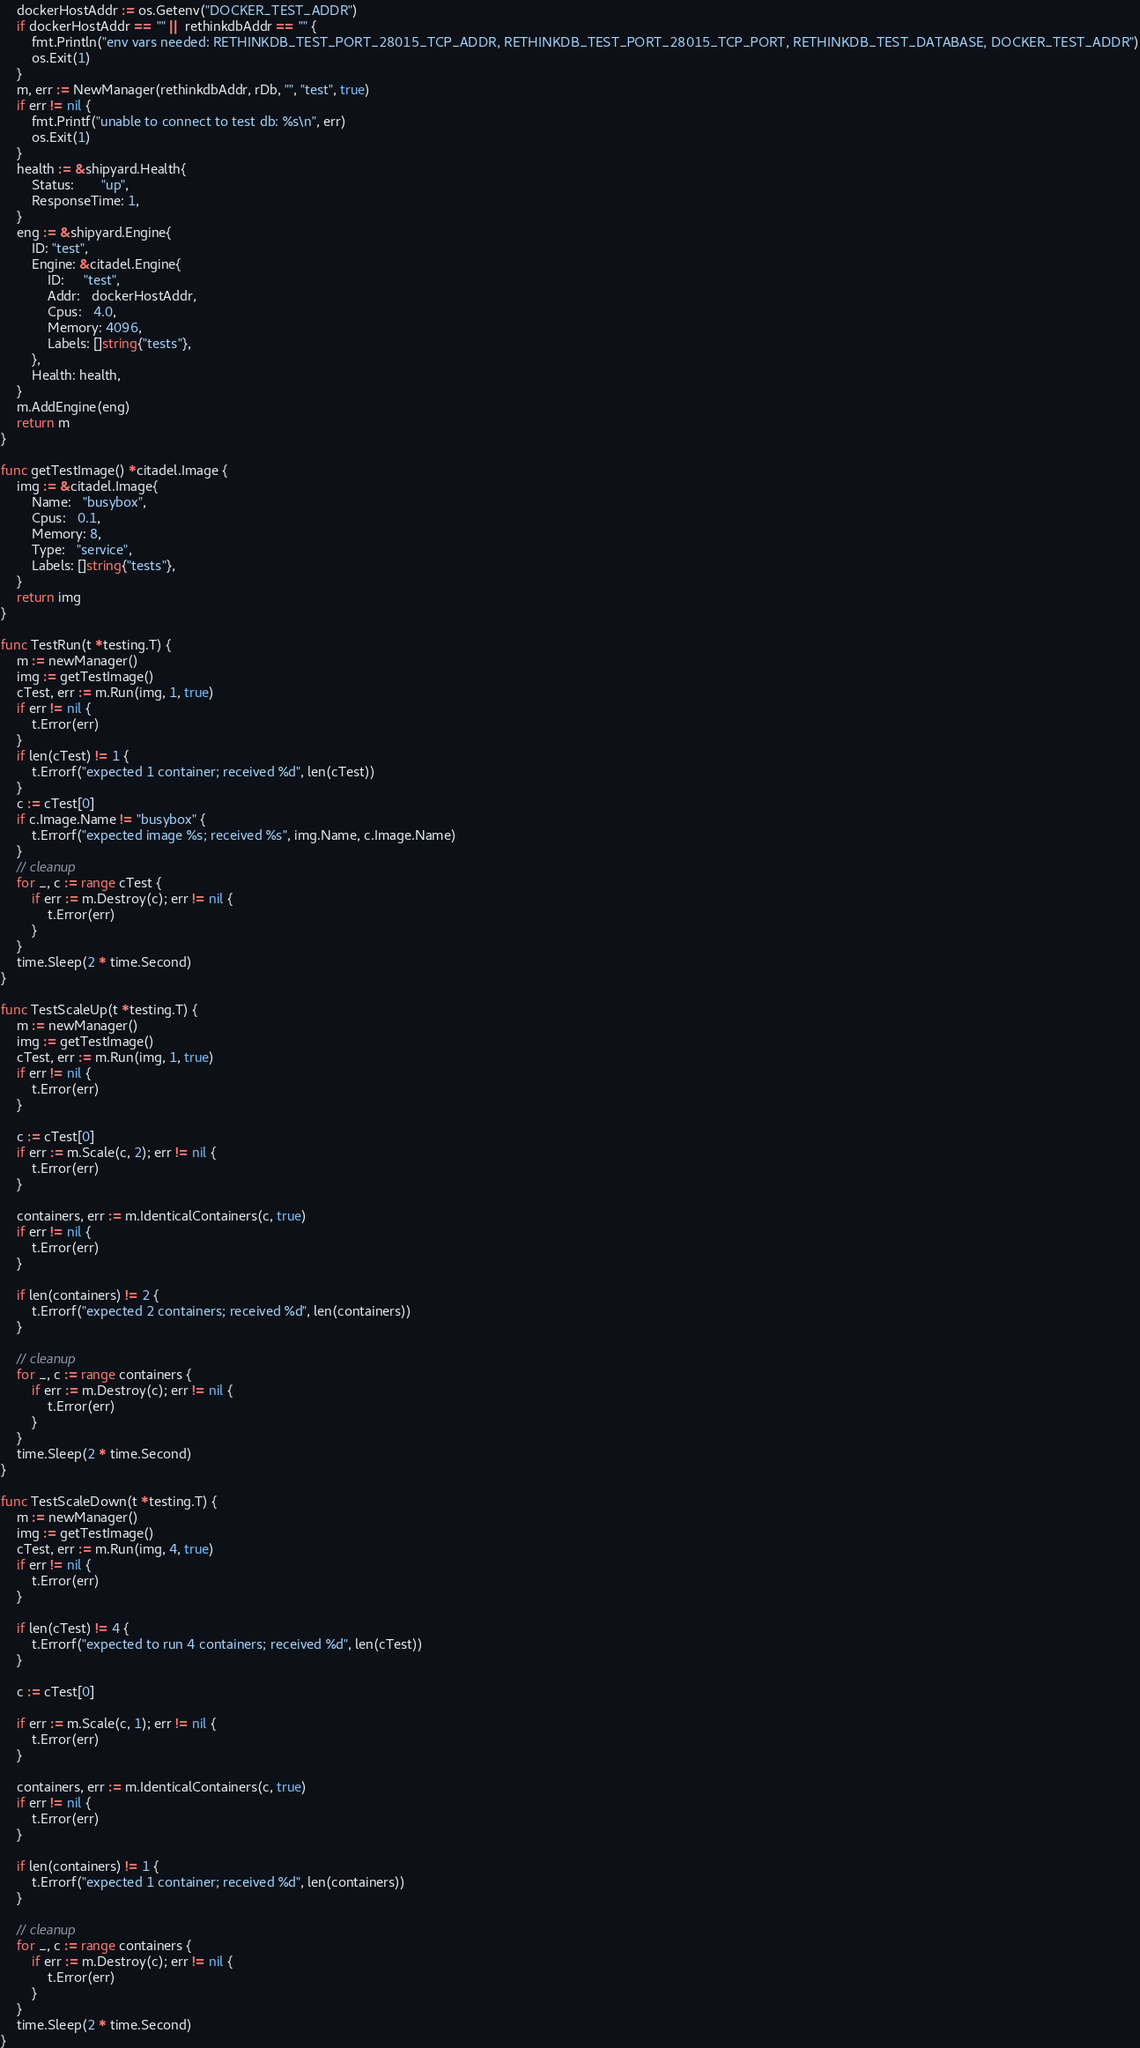<code> <loc_0><loc_0><loc_500><loc_500><_Go_>	dockerHostAddr := os.Getenv("DOCKER_TEST_ADDR")
	if dockerHostAddr == "" || rethinkdbAddr == "" {
		fmt.Println("env vars needed: RETHINKDB_TEST_PORT_28015_TCP_ADDR, RETHINKDB_TEST_PORT_28015_TCP_PORT, RETHINKDB_TEST_DATABASE, DOCKER_TEST_ADDR")
		os.Exit(1)
	}
	m, err := NewManager(rethinkdbAddr, rDb, "", "test", true)
	if err != nil {
		fmt.Printf("unable to connect to test db: %s\n", err)
		os.Exit(1)
	}
	health := &shipyard.Health{
		Status:       "up",
		ResponseTime: 1,
	}
	eng := &shipyard.Engine{
		ID: "test",
		Engine: &citadel.Engine{
			ID:     "test",
			Addr:   dockerHostAddr,
			Cpus:   4.0,
			Memory: 4096,
			Labels: []string{"tests"},
		},
		Health: health,
	}
	m.AddEngine(eng)
	return m
}

func getTestImage() *citadel.Image {
	img := &citadel.Image{
		Name:   "busybox",
		Cpus:   0.1,
		Memory: 8,
		Type:   "service",
		Labels: []string{"tests"},
	}
	return img
}

func TestRun(t *testing.T) {
	m := newManager()
	img := getTestImage()
	cTest, err := m.Run(img, 1, true)
	if err != nil {
		t.Error(err)
	}
	if len(cTest) != 1 {
		t.Errorf("expected 1 container; received %d", len(cTest))
	}
	c := cTest[0]
	if c.Image.Name != "busybox" {
		t.Errorf("expected image %s; received %s", img.Name, c.Image.Name)
	}
	// cleanup
	for _, c := range cTest {
		if err := m.Destroy(c); err != nil {
			t.Error(err)
		}
	}
	time.Sleep(2 * time.Second)
}

func TestScaleUp(t *testing.T) {
	m := newManager()
	img := getTestImage()
	cTest, err := m.Run(img, 1, true)
	if err != nil {
		t.Error(err)
	}

	c := cTest[0]
	if err := m.Scale(c, 2); err != nil {
		t.Error(err)
	}

	containers, err := m.IdenticalContainers(c, true)
	if err != nil {
		t.Error(err)
	}

	if len(containers) != 2 {
		t.Errorf("expected 2 containers; received %d", len(containers))
	}

	// cleanup
	for _, c := range containers {
		if err := m.Destroy(c); err != nil {
			t.Error(err)
		}
	}
	time.Sleep(2 * time.Second)
}

func TestScaleDown(t *testing.T) {
	m := newManager()
	img := getTestImage()
	cTest, err := m.Run(img, 4, true)
	if err != nil {
		t.Error(err)
	}

	if len(cTest) != 4 {
		t.Errorf("expected to run 4 containers; received %d", len(cTest))
	}

	c := cTest[0]

	if err := m.Scale(c, 1); err != nil {
		t.Error(err)
	}

	containers, err := m.IdenticalContainers(c, true)
	if err != nil {
		t.Error(err)
	}

	if len(containers) != 1 {
		t.Errorf("expected 1 container; received %d", len(containers))
	}

	// cleanup
	for _, c := range containers {
		if err := m.Destroy(c); err != nil {
			t.Error(err)
		}
	}
	time.Sleep(2 * time.Second)
}
</code> 